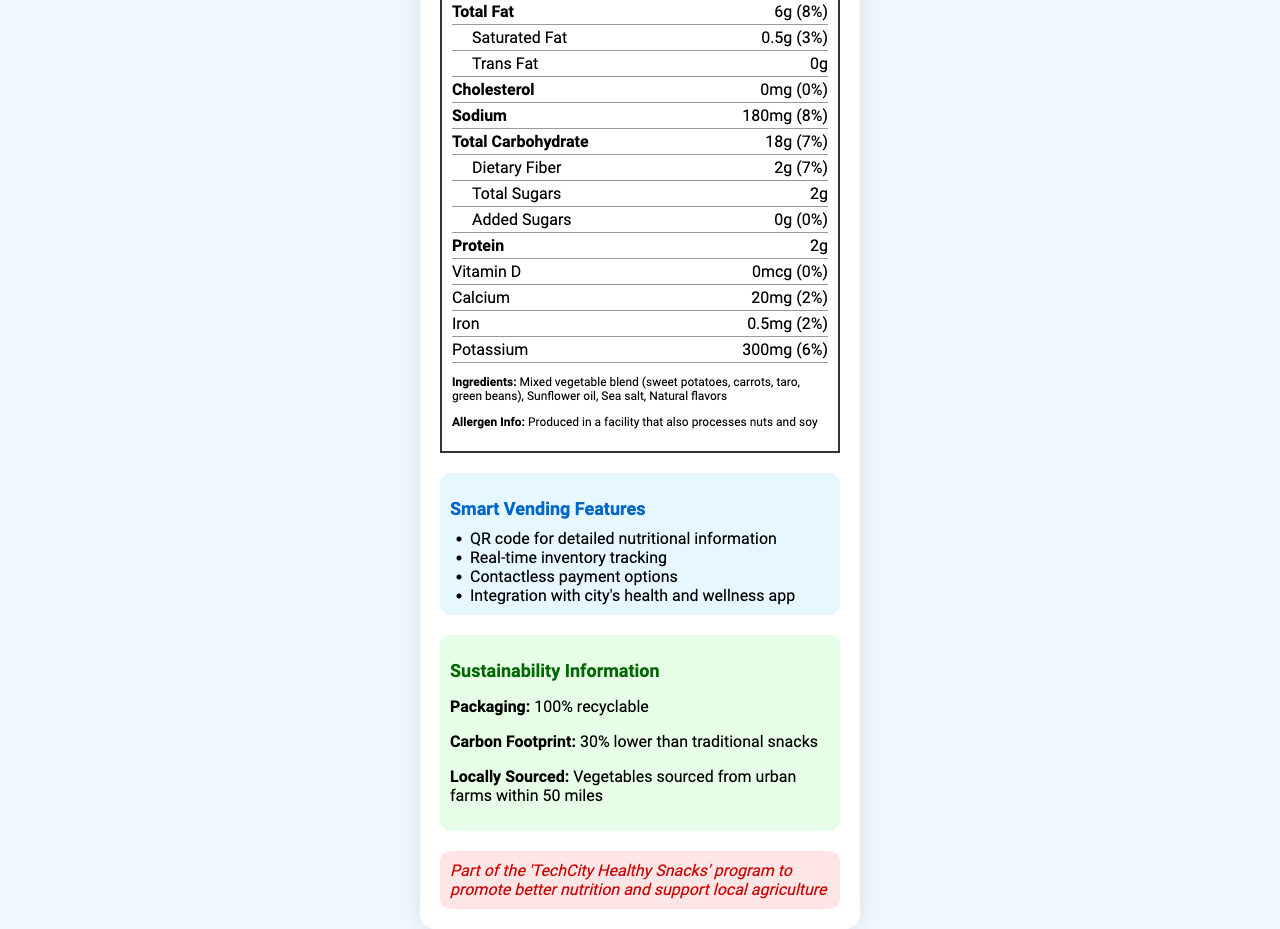what is the serving size? The serving size is listed under the "Serving Size" section on the label as "1 oz (28g)".
Answer: 1 oz (28g) how many servings are there per container? The number of servings per container is indicated as "3 servings per container" in the document.
Answer: 3 how much total fat is there per serving? The total fat per serving is listed as "Total Fat: 6g (8%)".
Answer: 6g what is the amount of dietary fiber per serving? The dietary fiber amount per serving is listed as "Dietary Fiber: 2g (7%)".
Answer: 2g which ingredients are included in the SmartSnack Veggie Chips? The ingredients are listed under the "Ingredients" section.
Answer: Mixed vegetable blend (sweet potatoes, carrots, taro, green beans), Sunflower oil, Sea salt, Natural flavors how many calories are in one serving? Each serving contains 130 calories as listed under the "Calories" section.
Answer: 130 what is the protein content per serving? The protein content per serving is indicated as "Protein: 2g" on the label.
Answer: 2g true or false: This product contains trans fat. The document specifies "Trans Fat: 0g".
Answer: False how much sodium is there per serving? The sodium content per serving is listed as "Sodium: 180mg (8%)".
Answer: 180mg which of the following vitamins and minerals are included in the SmartSnack Veggie Chips? A. Vitamin D B. Calcium C. Iron D. Potassium The document lists Potassium with an amount of "300mg (6%)".
Answer: D which one of the following is a health claim made about the SmartSnack Veggie Chips? A. Contains artificial preservatives B. Good source of potassium C. High in saturated fat The document includes "Good source of potassium" as a health claim.
Answer: B describe the smart vending features presented in the document. The smart vending features section lists four features: a QR code for nutritional information, real-time inventory tracking, contactless payment options, and integration with the city’s health and wellness app.
Answer: QR code for detailed nutritional information, Real-time inventory tracking, Contactless payment options, Integration with city's health and wellness app is this product non-GMO? The health claims section lists "Non-GMO" as one of the product attributes.
Answer: Yes what initiative is the SmartSnack Veggie Chips a part of? The document mentions that it is part of the "TechCity Healthy Snacks" program to promote better nutrition and support local agriculture.
Answer: 'TechCity Healthy Snacks' program what is the total calorie count for the whole container? Each serving has 130 calories, and with 3 servings per container, the total is 130 * 3 = 390 calories.
Answer: 390 summarize the main idea of the document. The document details nutritional information, ingredients, and smart vending features, emphasizing sustainability and the mayor's health initiative.
Answer: The document presents the nutrition facts, ingredients, and allergen information of SmartSnack Veggie Chips. It highlights smart vending features, sustainability information, and the product's alignment with the 'TechCity Healthy Snacks' program, promoting better nutrition and local agriculture. how much added sugar is there in the product? The amount of added sugars per serving is listed as "Added Sugars: 0g (0%)".
Answer: 0g where are the vegetables for SmartSnack Veggie Chips sourced from? The sustainability information section mentions that the vegetables are "sourced from urban farms within 50 miles".
Answer: Urban farms within 50 miles how much daily value of Vitamin D does this product provide? The document indicates "Vitamin D: 0mcg (0%)".
Answer: 0% what is the product name? The product name appears at the top of the document as "SmartSnack Veggie Chips".
Answer: SmartSnack Veggie Chips does this product contain any cholesterol? The document lists "Cholesterol: 0mg (0%)".
Answer: No what is the calorie count from total fat per serving? The document does not provide enough information to calculate the calorie count specifically from total fat per serving.
Answer: Cannot be determined 